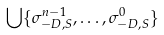<formula> <loc_0><loc_0><loc_500><loc_500>\bigcup \{ \sigma _ { - D , S } ^ { n - 1 } , \dots , \sigma _ { - D , S } ^ { 0 } \}</formula> 